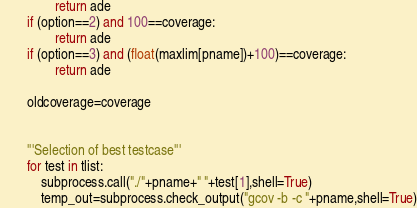Convert code to text. <code><loc_0><loc_0><loc_500><loc_500><_Python_>				return ade
		if (option==2) and 100==coverage:
				return ade
		if (option==3) and (float(maxlim[pname])+100)==coverage:
				return ade
		
		oldcoverage=coverage

		
		'''Selection of best testcase'''
		for test in tlist:
			subprocess.call("./"+pname+" "+test[1],shell=True)
			temp_out=subprocess.check_output("gcov -b -c "+pname,shell=True)
</code> 